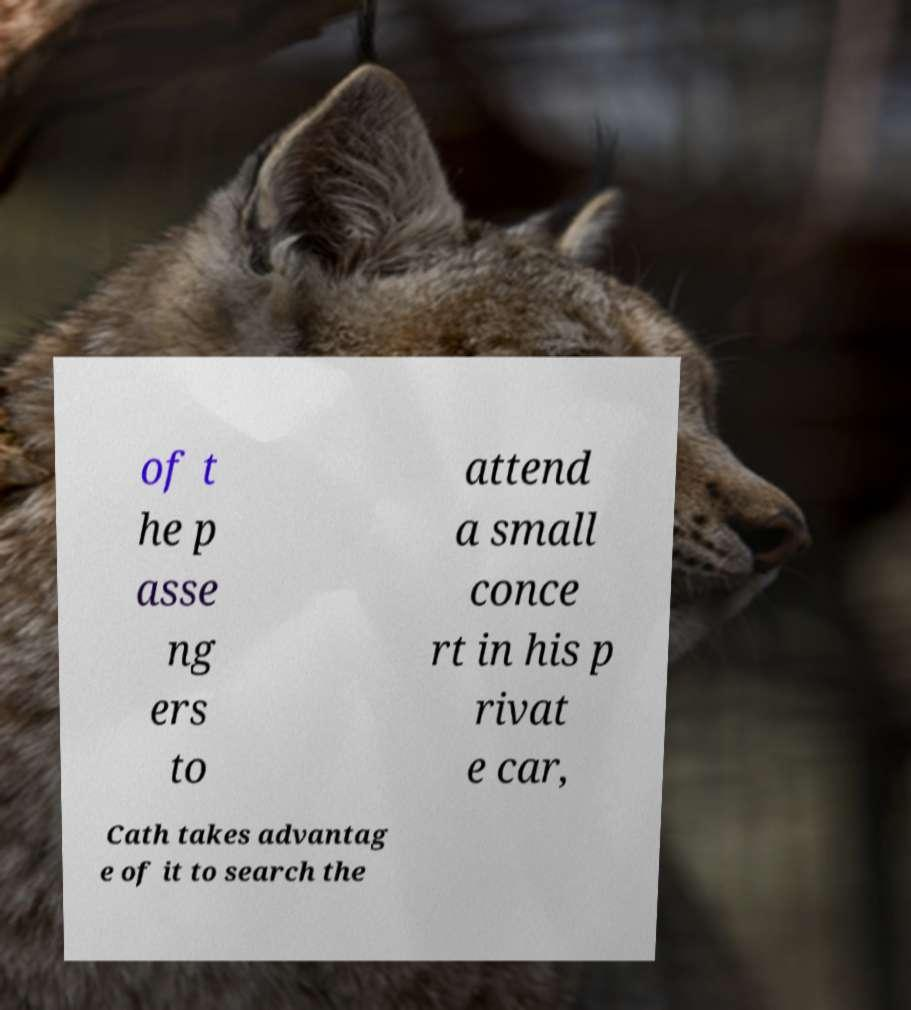Can you accurately transcribe the text from the provided image for me? of t he p asse ng ers to attend a small conce rt in his p rivat e car, Cath takes advantag e of it to search the 